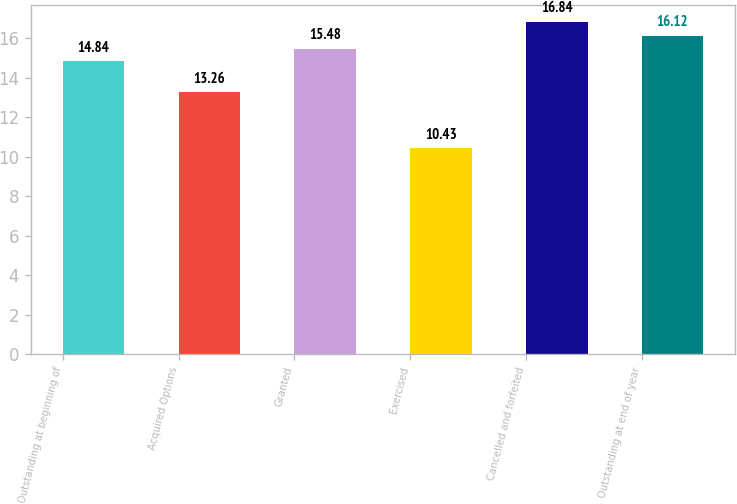<chart> <loc_0><loc_0><loc_500><loc_500><bar_chart><fcel>Outstanding at beginning of<fcel>Acquired Options<fcel>Granted<fcel>Exercised<fcel>Cancelled and forfeited<fcel>Outstanding at end of year<nl><fcel>14.84<fcel>13.26<fcel>15.48<fcel>10.43<fcel>16.84<fcel>16.12<nl></chart> 